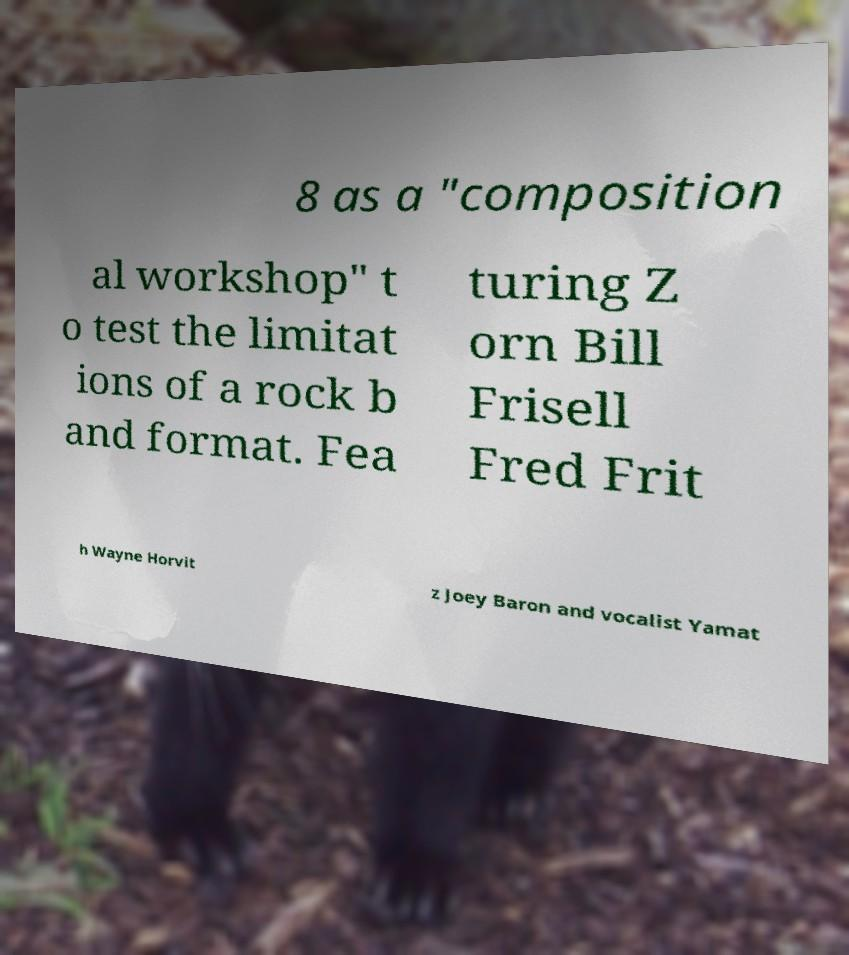What messages or text are displayed in this image? I need them in a readable, typed format. 8 as a "composition al workshop" t o test the limitat ions of a rock b and format. Fea turing Z orn Bill Frisell Fred Frit h Wayne Horvit z Joey Baron and vocalist Yamat 